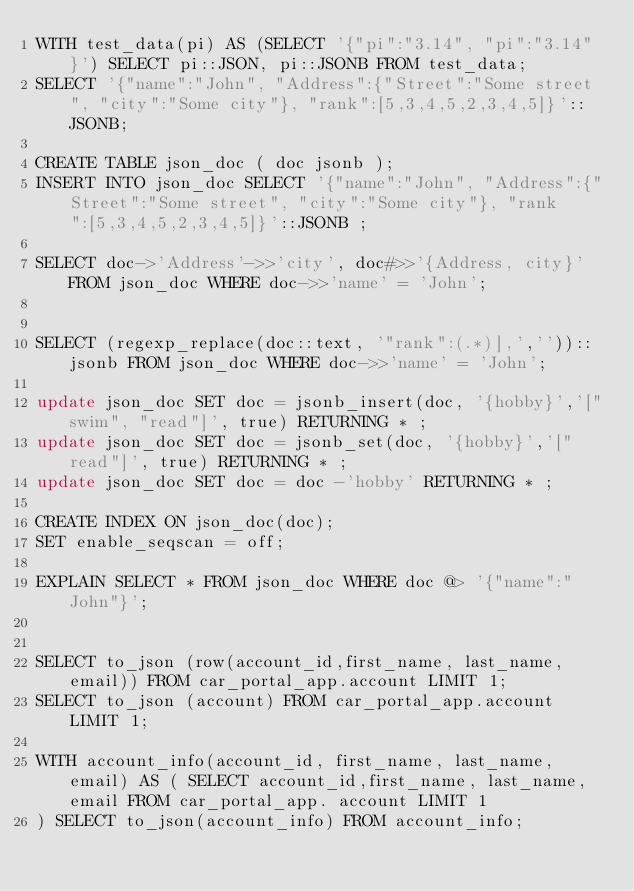<code> <loc_0><loc_0><loc_500><loc_500><_SQL_>WITH test_data(pi) AS (SELECT '{"pi":"3.14", "pi":"3.14" }') SELECT pi::JSON, pi::JSONB FROM test_data;
SELECT '{"name":"John", "Address":{"Street":"Some street", "city":"Some city"}, "rank":[5,3,4,5,2,3,4,5]}'::JSONB;

CREATE TABLE json_doc ( doc jsonb );
INSERT INTO json_doc SELECT '{"name":"John", "Address":{"Street":"Some street", "city":"Some city"}, "rank":[5,3,4,5,2,3,4,5]}'::JSONB ;

SELECT doc->'Address'->>'city', doc#>>'{Address, city}' FROM json_doc WHERE doc->>'name' = 'John';


SELECT (regexp_replace(doc::text, '"rank":(.*)],',''))::jsonb FROM json_doc WHERE doc->>'name' = 'John';

update json_doc SET doc = jsonb_insert(doc, '{hobby}','["swim", "read"]', true) RETURNING * ;
update json_doc SET doc = jsonb_set(doc, '{hobby}','["read"]', true) RETURNING * ;
update json_doc SET doc = doc -'hobby' RETURNING * ;

CREATE INDEX ON json_doc(doc);
SET enable_seqscan = off;

EXPLAIN SELECT * FROM json_doc WHERE doc @> '{"name":"John"}';


SELECT to_json (row(account_id,first_name, last_name, email)) FROM car_portal_app.account LIMIT 1;
SELECT to_json (account) FROM car_portal_app.account LIMIT 1;

WITH account_info(account_id, first_name, last_name, email) AS ( SELECT account_id,first_name, last_name, email FROM car_portal_app. account LIMIT 1
) SELECT to_json(account_info) FROM account_info;</code> 